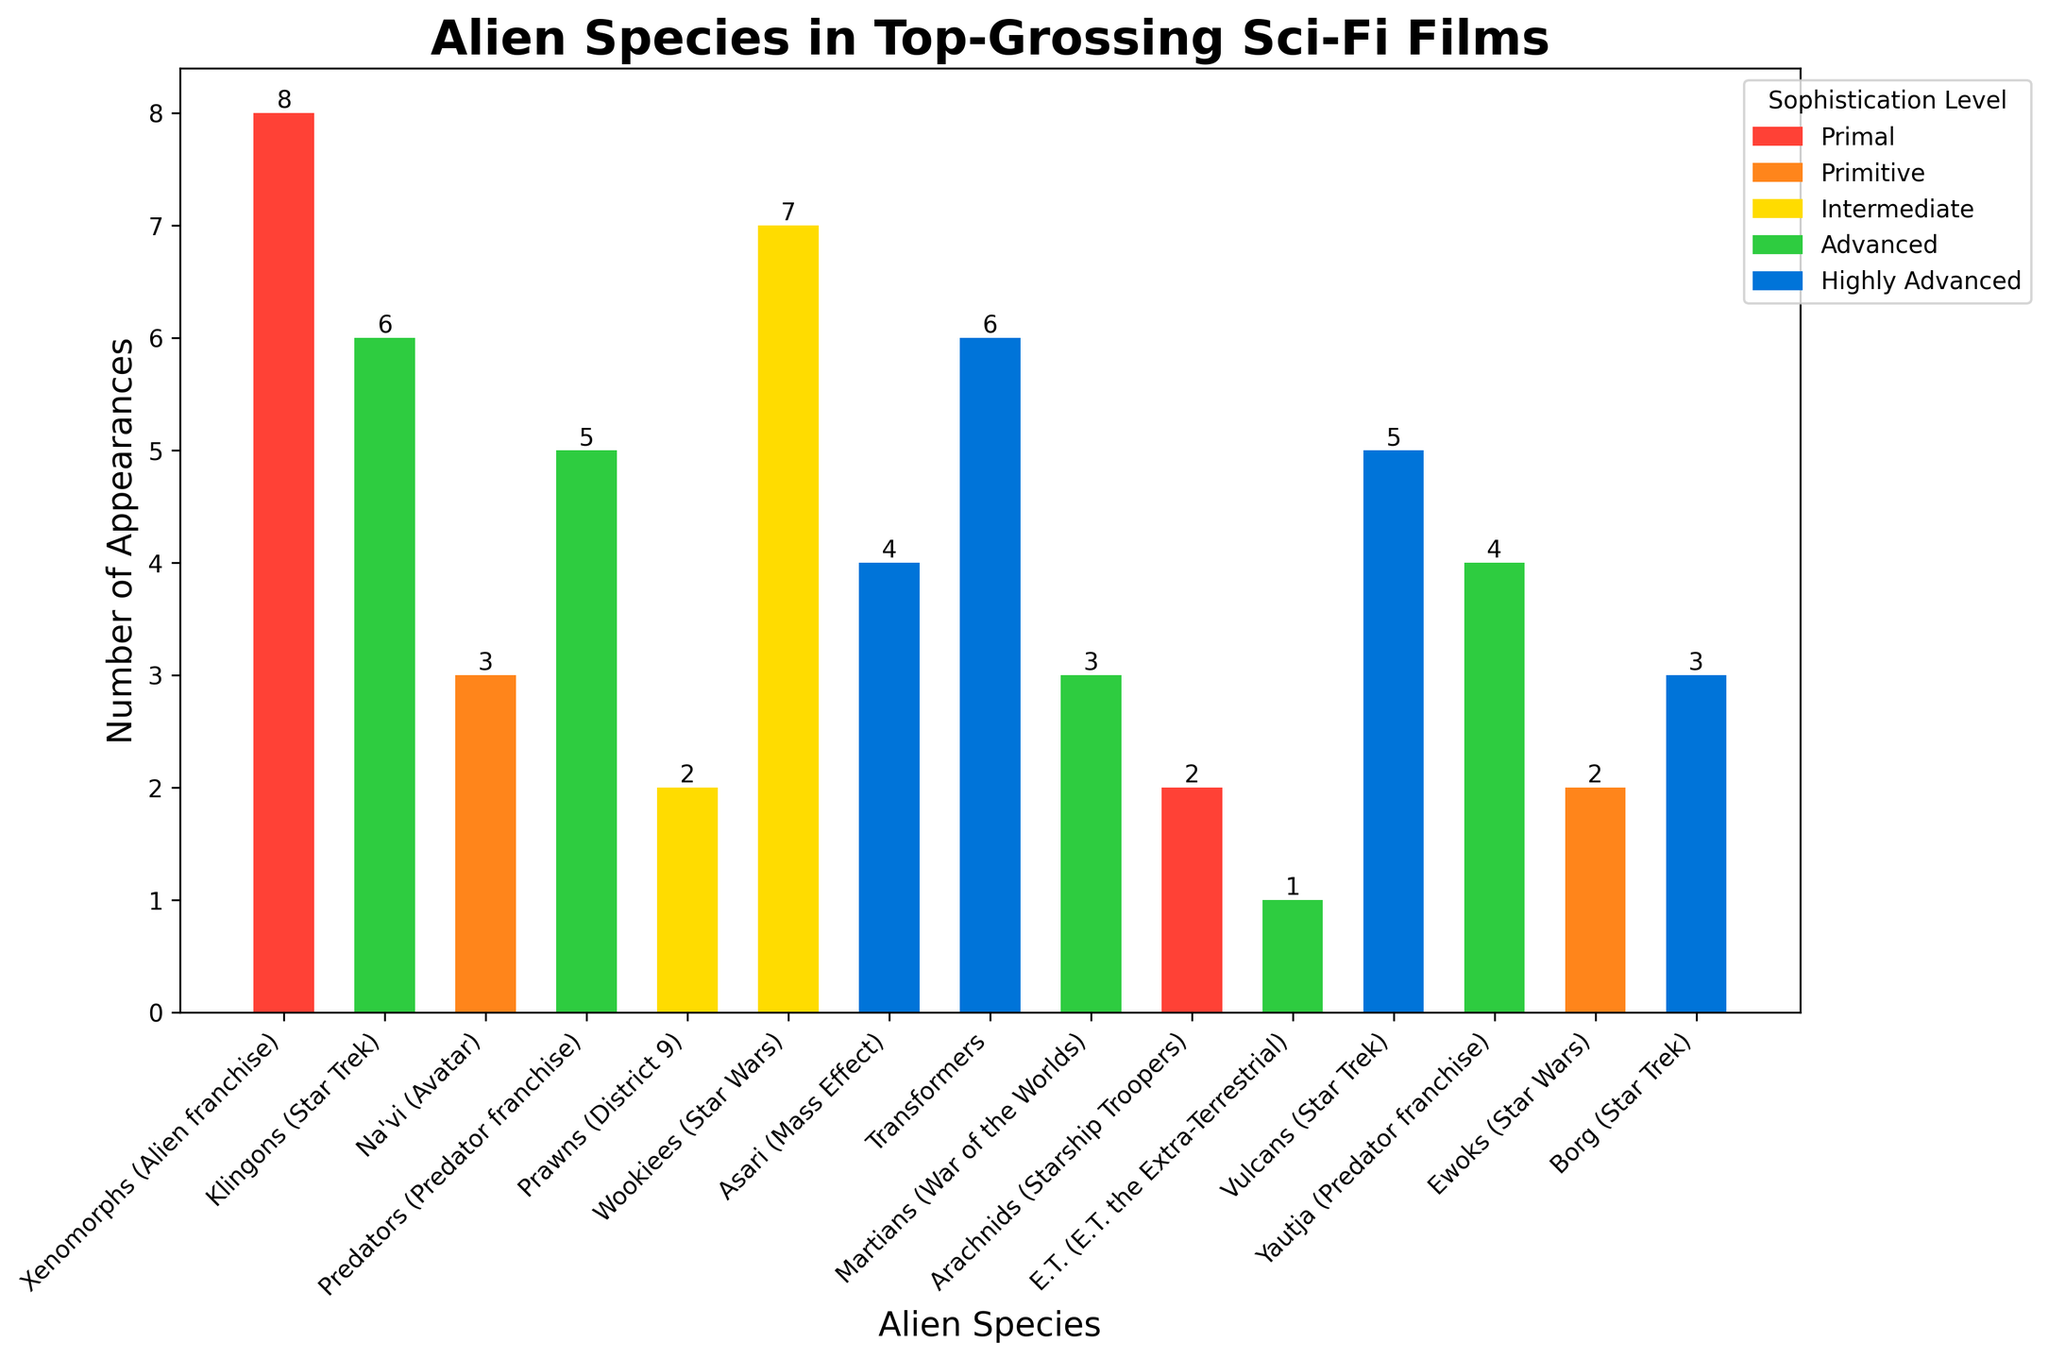Which alien species appears the most frequently in top-grossing sci-fi films? The figure shows that the Wookiees (Star Wars) have the highest bar, indicating they appear the most frequently.
Answer: Wookiees (Star Wars) How many alien species have a sophistication level of 'Advanced'? By referring to the legend and the respective bars coded in green, we count the species listed as 'Advanced': Klingons, Predators, Martians, E.T., and Yautja. There are 5 bars matching this level.
Answer: 5 Which alien species with a 'Primal' sophistication level appears more frequently: Xenomorphs or Arachnids? The red bars represent 'Primal' species. By comparing their heights, Xenomorphs have a higher value of 8 appearances compared to Arachnids, which have 2 appearances.
Answer: Xenomorphs What is the combined total number of appearances for species with a 'Highly Advanced' sophistication level? Summing the appearances of the 'Highly Advanced' species (Asari: 4, Transformers: 6, Vulcans: 5, Borg: 3), we get 4 + 6 + 5 + 3 = 18.
Answer: 18 Which species category has the widest representation across sophistication levels? By scanning the bars and colors, the 'Advanced' category includes appearances from Klingons, Predators, Martians, E.T., and Yautja, spanning a broader range of individual species.
Answer: Advanced Among 'Primitive' sophistication level species, what is the ratio of Na'vi appearances to Ewok appearances? The 'Primitive' category is represented by orange bars: Na'vi (3) and Ewoks (2). The ratio of their appearances is 3 to 2.
Answer: 3:2 Compare the total appearances of alien species in the 'Intermediate' and 'Primitive' sophistication levels. Which level has more appearances? Summing the appearances for 'Intermediate' (Prawns: 2, Wookiees: 7 = 9) and 'Primitive' (Na'vi: 3, Ewoks: 2 = 5), the 'Intermediate' level is higher at 9 compared to 'Primitive' at 5.
Answer: Intermediate What is the difference in the number of appearances between the least and most sophisticated alien species categories? The least sophisticated category 'Primal' (10 total: Xenomorphs 8, Arachnids 2) and the most sophisticated 'Highly Advanced' (18 total: Asari 4, Transformers 6, Vulcans 5, Borg 3). The difference is 18 - 10 = 8.
Answer: 8 Which alien species with at least an ‘Advanced’ sophistication level appears the least frequently? By examining the green and blue bars, E.T. (Advanced) has the smallest number at 1 appearance among the advanced and more advanced species.
Answer: E.T. (E.T. the Extra-Terrestrial) What is the average number of appearances for all species in the 'Highly Advanced' category? The 'Highly Advanced' species’ appearances are 4 (Asari), 6 (Transformers), 5 (Vulcans), and 3 (Borg). The sum is 18, and the average is 18 / 4 = 4.5.
Answer: 4.5 